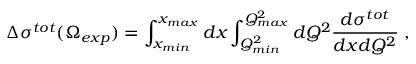<formula> <loc_0><loc_0><loc_500><loc_500>\Delta \sigma ^ { t o t } ( \Omega _ { e x p } ) = \int _ { x _ { \min } } ^ { x _ { \max } } d x \int _ { Q _ { \min } ^ { 2 } } ^ { Q _ { \max } ^ { 2 } } d Q ^ { 2 } \frac { d \sigma ^ { t o t } } { d x d Q ^ { 2 } } \, ,</formula> 